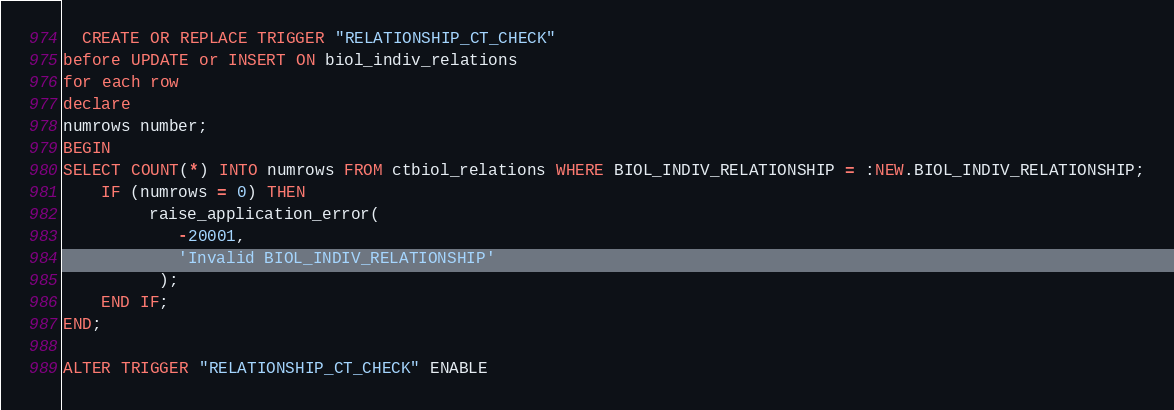<code> <loc_0><loc_0><loc_500><loc_500><_SQL_>
  CREATE OR REPLACE TRIGGER "RELATIONSHIP_CT_CHECK" 
before UPDATE or INSERT ON biol_indiv_relations
for each row
declare
numrows number;
BEGIN
SELECT COUNT(*) INTO numrows FROM ctbiol_relations WHERE BIOL_INDIV_RELATIONSHIP = :NEW.BIOL_INDIV_RELATIONSHIP;
	IF (numrows = 0) THEN
		 raise_application_error(
	        -20001,
	        'Invalid BIOL_INDIV_RELATIONSHIP'
	      );
	END IF;
END;

ALTER TRIGGER "RELATIONSHIP_CT_CHECK" ENABLE</code> 